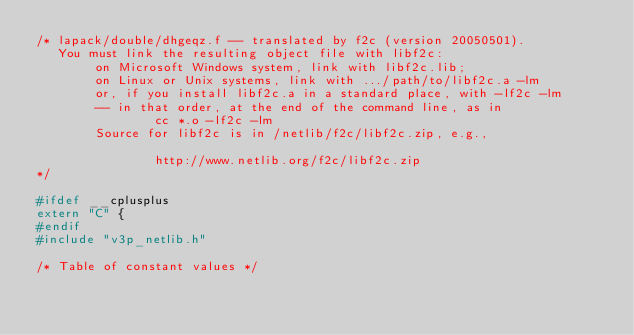Convert code to text. <code><loc_0><loc_0><loc_500><loc_500><_C_>/* lapack/double/dhgeqz.f -- translated by f2c (version 20050501).
   You must link the resulting object file with libf2c:
        on Microsoft Windows system, link with libf2c.lib;
        on Linux or Unix systems, link with .../path/to/libf2c.a -lm
        or, if you install libf2c.a in a standard place, with -lf2c -lm
        -- in that order, at the end of the command line, as in
                cc *.o -lf2c -lm
        Source for libf2c is in /netlib/f2c/libf2c.zip, e.g.,

                http://www.netlib.org/f2c/libf2c.zip
*/

#ifdef __cplusplus
extern "C" {
#endif
#include "v3p_netlib.h"

/* Table of constant values */
</code> 